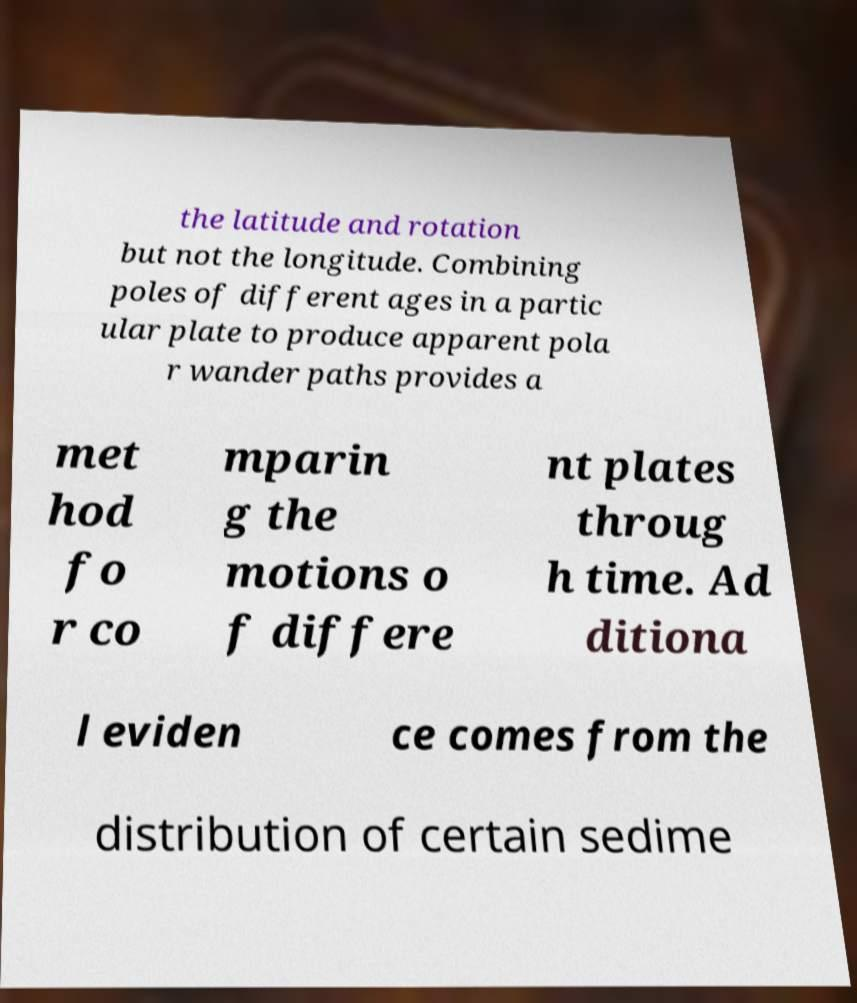I need the written content from this picture converted into text. Can you do that? the latitude and rotation but not the longitude. Combining poles of different ages in a partic ular plate to produce apparent pola r wander paths provides a met hod fo r co mparin g the motions o f differe nt plates throug h time. Ad ditiona l eviden ce comes from the distribution of certain sedime 